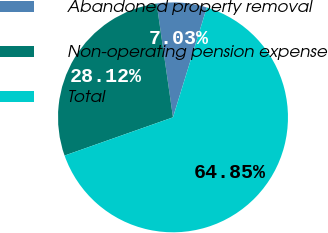Convert chart to OTSL. <chart><loc_0><loc_0><loc_500><loc_500><pie_chart><fcel>Abandoned property removal<fcel>Non-operating pension expense<fcel>Total<nl><fcel>7.03%<fcel>28.12%<fcel>64.84%<nl></chart> 